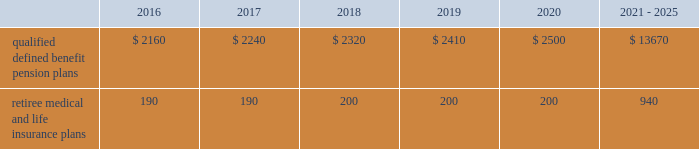Contributions and expected benefit payments the funding of our qualified defined benefit pension plans is determined in accordance with erisa , as amended by the ppa , and in a manner consistent with cas and internal revenue code rules .
In 2015 , we made $ 5 million in contributions to our new sikorsky bargained qualified defined benefit pension plan and we plan to make approximately $ 25 million in contributions to this plan in 2016 .
The table presents estimated future benefit payments , which reflect expected future employee service , as of december 31 , 2015 ( in millions ) : .
Defined contribution plans we maintain a number of defined contribution plans , most with 401 ( k ) features , that cover substantially all of our employees .
Under the provisions of our 401 ( k ) plans , we match most employees 2019 eligible contributions at rates specified in the plan documents .
Our contributions were $ 393 million in 2015 , $ 385 million in 2014 and $ 383 million in 2013 , the majority of which were funded in our common stock .
Our defined contribution plans held approximately 40.0 million and 41.7 million shares of our common stock as of december 31 , 2015 and 2014 .
Note 12 2013 stockholders 2019 equity at december 31 , 2015 and 2014 , our authorized capital was composed of 1.5 billion shares of common stock and 50 million shares of series preferred stock .
Of the 305 million shares of common stock issued and outstanding as of december 31 , 2015 , 303 million shares were considered outstanding for balance sheet presentation purposes ; the remaining shares were held in a separate trust .
Of the 316 million shares of common stock issued and outstanding as of december 31 , 2014 , 314 million shares were considered outstanding for balance sheet presentation purposes ; the remaining shares were held in a separate trust .
No shares of preferred stock were issued and outstanding at december 31 , 2015 or 2014 .
Repurchases of common stock during 2015 , we repurchased 15.2 million shares of our common stock for $ 3.1 billion .
During 2014 and 2013 , we paid $ 1.9 billion and $ 1.8 billion to repurchase 11.5 million and 16.2 million shares of our common stock .
On september 24 , 2015 , our board of directors approved a $ 3.0 billion increase to our share repurchase program .
Inclusive of this increase , the total remaining authorization for future common share repurchases under our program was $ 3.6 billion as of december 31 , 2015 .
As we repurchase our common shares , we reduce common stock for the $ 1 of par value of the shares repurchased , with the excess purchase price over par value recorded as a reduction of additional paid-in capital .
Due to the volume of repurchases made under our share repurchase program , additional paid-in capital was reduced to zero , with the remainder of the excess purchase price over par value of $ 2.4 billion and $ 1.1 billion recorded as a reduction of retained earnings in 2015 and 2014 .
We paid dividends totaling $ 1.9 billion ( $ 6.15 per share ) in 2015 , $ 1.8 billion ( $ 5.49 per share ) in 2014 and $ 1.5 billion ( $ 4.78 per share ) in 2013 .
We have increased our quarterly dividend rate in each of the last three years , including a 10% ( 10 % ) increase in the quarterly dividend rate in the fourth quarter of 2015 .
We declared quarterly dividends of $ 1.50 per share during each of the first three quarters of 2015 and $ 1.65 per share during the fourth quarter of 2015 ; $ 1.33 per share during each of the first three quarters of 2014 and $ 1.50 per share during the fourth quarter of 2014 ; and $ 1.15 per share during each of the first three quarters of 2013 and $ 1.33 per share during the fourth quarter of 2013. .
What is the change in millions of qualified defined benefit pension plans expected to be paid out between 2017 to 2018? 
Computations: (2320 - 2240)
Answer: 80.0. 